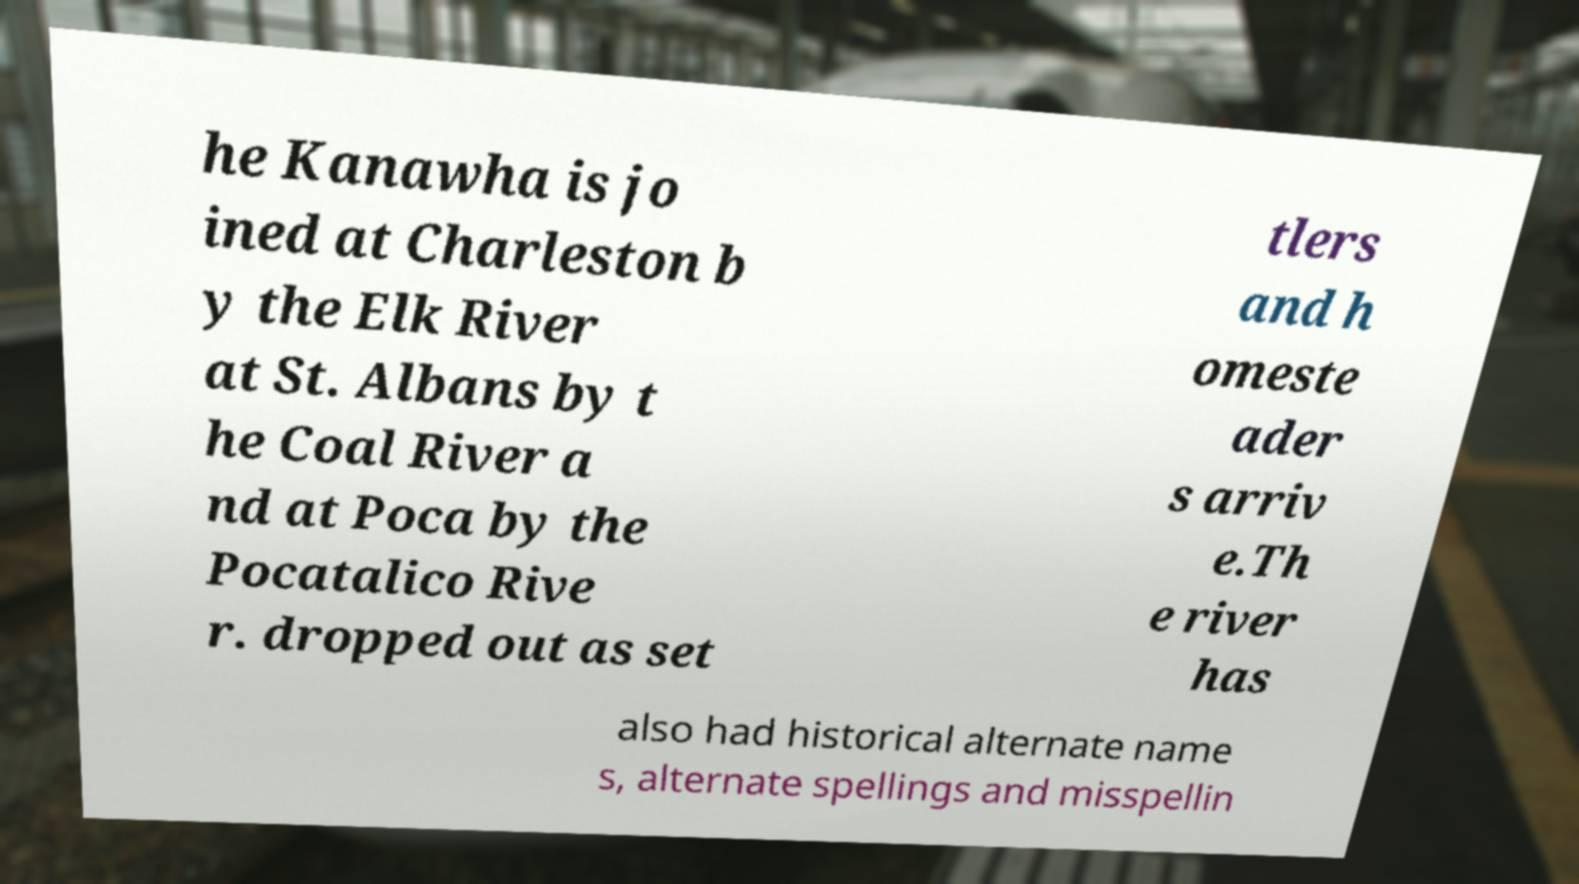Can you read and provide the text displayed in the image?This photo seems to have some interesting text. Can you extract and type it out for me? he Kanawha is jo ined at Charleston b y the Elk River at St. Albans by t he Coal River a nd at Poca by the Pocatalico Rive r. dropped out as set tlers and h omeste ader s arriv e.Th e river has also had historical alternate name s, alternate spellings and misspellin 